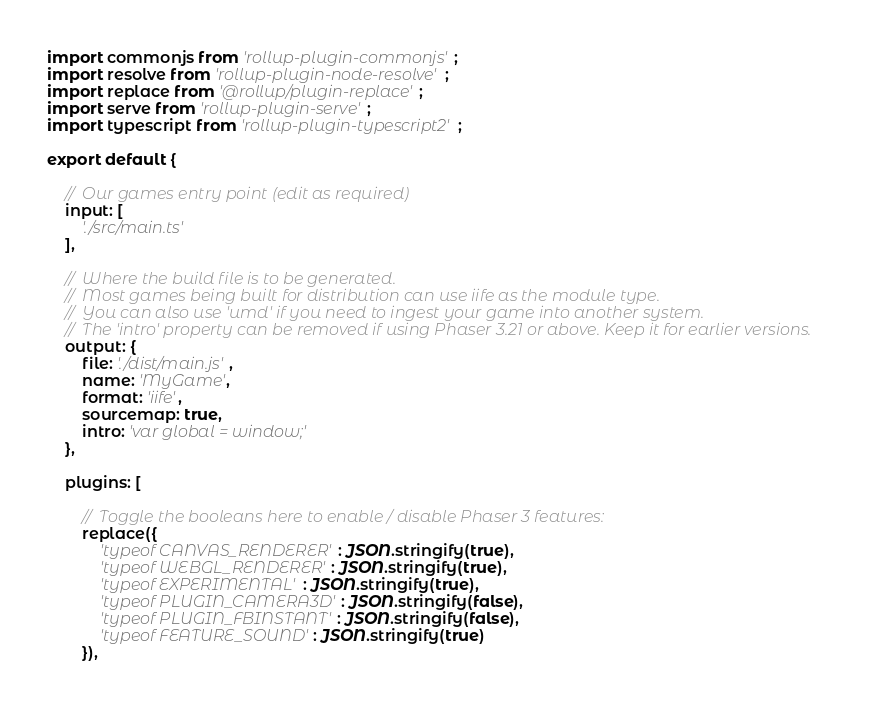<code> <loc_0><loc_0><loc_500><loc_500><_JavaScript_>import commonjs from 'rollup-plugin-commonjs';
import resolve from 'rollup-plugin-node-resolve';
import replace from '@rollup/plugin-replace';
import serve from 'rollup-plugin-serve';
import typescript from 'rollup-plugin-typescript2';

export default {

    //  Our games entry point (edit as required)
    input: [
        './src/main.ts'
    ],

    //  Where the build file is to be generated.
    //  Most games being built for distribution can use iife as the module type.
    //  You can also use 'umd' if you need to ingest your game into another system.
    //  The 'intro' property can be removed if using Phaser 3.21 or above. Keep it for earlier versions.
    output: {
        file: './dist/main.js',
        name: 'MyGame',
        format: 'iife',
        sourcemap: true,
        intro: 'var global = window;'
    },

    plugins: [

        //  Toggle the booleans here to enable / disable Phaser 3 features:
        replace({
            'typeof CANVAS_RENDERER': JSON.stringify(true),
            'typeof WEBGL_RENDERER': JSON.stringify(true),
            'typeof EXPERIMENTAL': JSON.stringify(true),
            'typeof PLUGIN_CAMERA3D': JSON.stringify(false),
            'typeof PLUGIN_FBINSTANT': JSON.stringify(false),
            'typeof FEATURE_SOUND': JSON.stringify(true)
        }),
</code> 